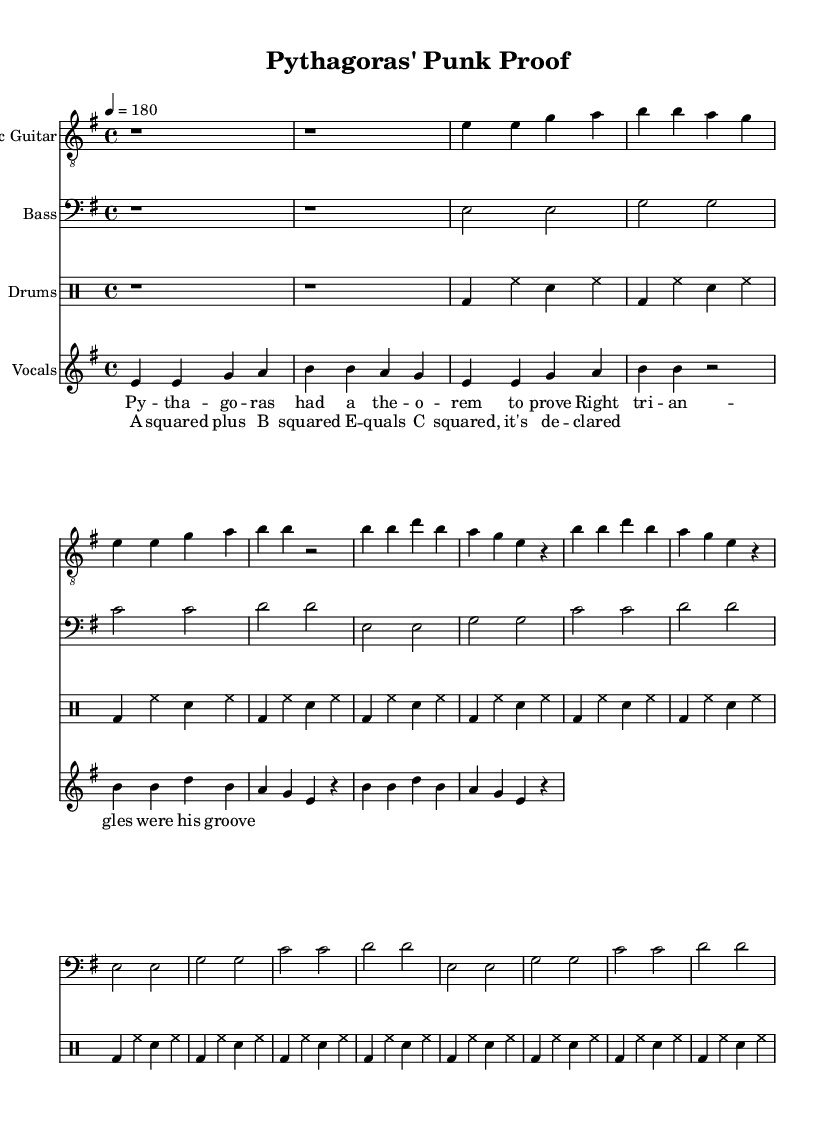What is the key signature of this music? The key signature is indicated at the beginning of the piece. It shows a key signature with one sharp, which corresponds to E minor.
Answer: E minor What is the time signature? The time signature is visible at the start of the piece and is expressed as 4/4, which indicates four beats in a measure.
Answer: 4/4 What is the tempo marking? The tempo marking is specified at the beginning of the score and is described as quarter note equals 180 beats per minute, indicating a fast-paced tempo.
Answer: 180 How many measures are in the verse section? By counting the measures in the verse section, which is separately indicated from the chorus, we find there are eight measures total in the verse.
Answer: 8 What type of musical texture is primarily used? The score shows multiple instrumental voices playing at the same time, typical of punk music's full and energetic sound, indicating a homophonic texture where chords and melody are prominent together.
Answer: Homophonic What mathematical concept is referenced in the lyrics? The lyrics of the chorus explicitly mention "A squared plus B squared equals C squared," referring to the Pythagorean theorem, a fundamental mathematical concept.
Answer: Pythagorean theorem How does the use of instrumentation contribute to the punk genre? The instrumentation includes electric guitar, bass, and drums, which are essential in punk music for creating a high-energy and aggressive sound that emphasizes rhythm and melody collectively.
Answer: Electric guitar, bass, drums 